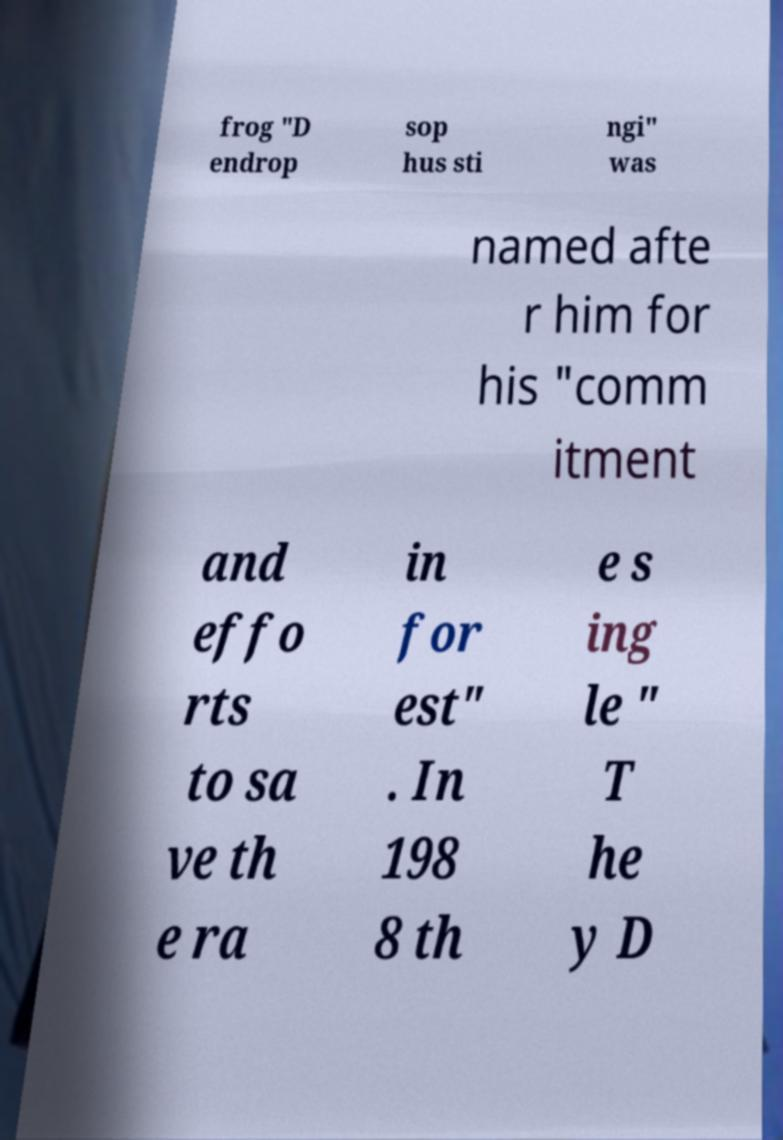What messages or text are displayed in this image? I need them in a readable, typed format. frog "D endrop sop hus sti ngi" was named afte r him for his "comm itment and effo rts to sa ve th e ra in for est" . In 198 8 th e s ing le " T he y D 